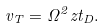Convert formula to latex. <formula><loc_0><loc_0><loc_500><loc_500>v _ { T } = \Omega ^ { 2 } z t _ { D } .</formula> 